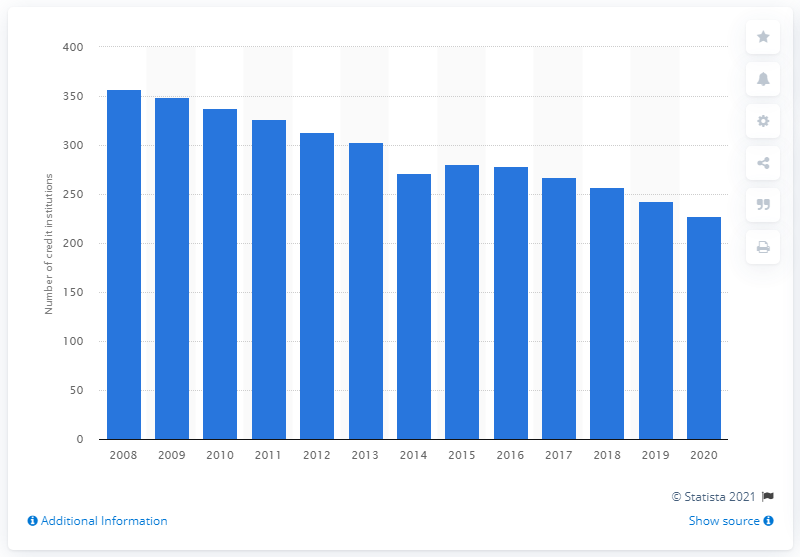Mention a couple of crucial points in this snapshot. At the end of 2008, there were 357 monetary financial credit institutions in Finland. At the end of December 2020, there were 228 microfinance institutions (MFIs) in Finland. 